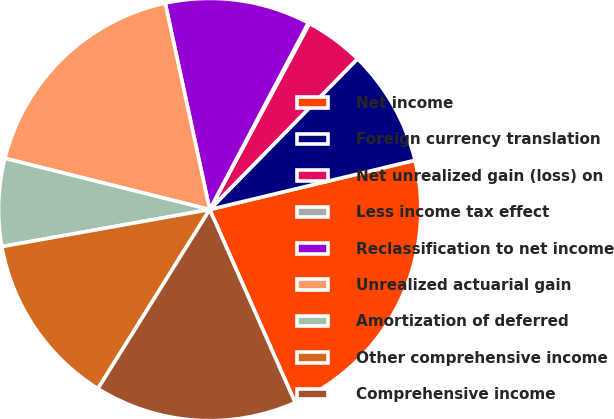<chart> <loc_0><loc_0><loc_500><loc_500><pie_chart><fcel>Net income<fcel>Foreign currency translation<fcel>Net unrealized gain (loss) on<fcel>Less income tax effect<fcel>Reclassification to net income<fcel>Unrealized actuarial gain<fcel>Amortization of deferred<fcel>Other comprehensive income<fcel>Comprehensive income<nl><fcel>22.12%<fcel>8.91%<fcel>4.51%<fcel>0.1%<fcel>11.11%<fcel>17.72%<fcel>6.71%<fcel>13.31%<fcel>15.51%<nl></chart> 